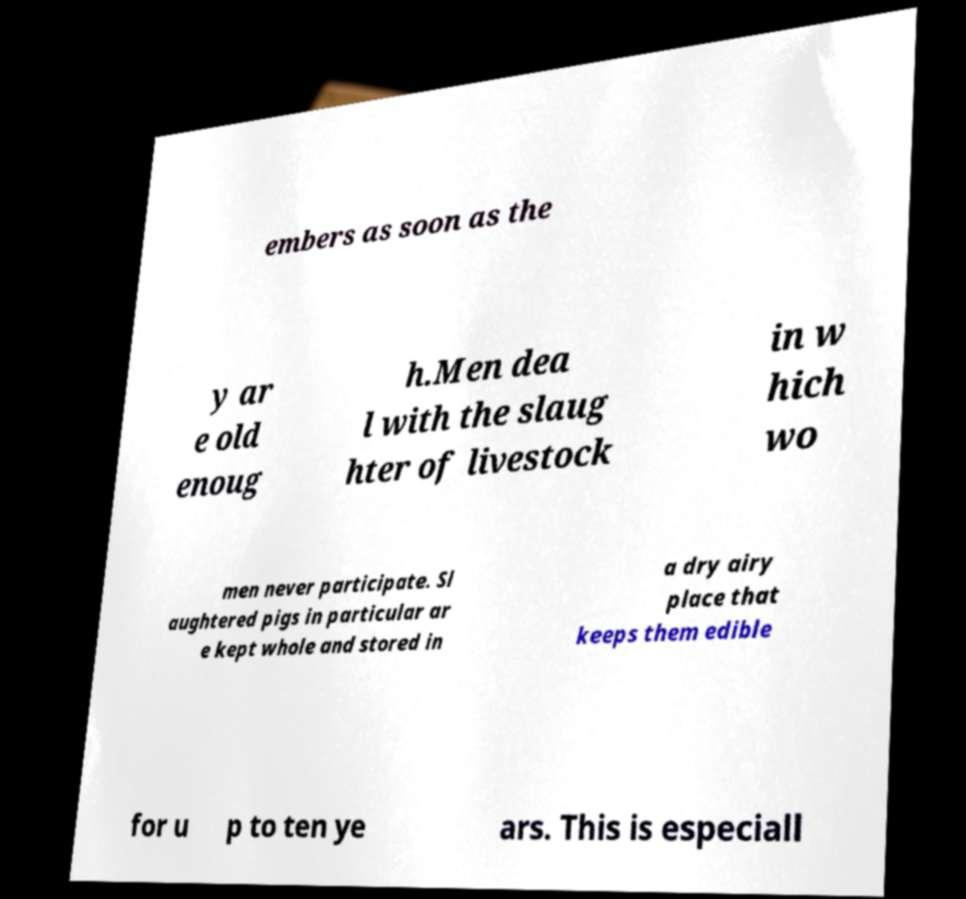For documentation purposes, I need the text within this image transcribed. Could you provide that? embers as soon as the y ar e old enoug h.Men dea l with the slaug hter of livestock in w hich wo men never participate. Sl aughtered pigs in particular ar e kept whole and stored in a dry airy place that keeps them edible for u p to ten ye ars. This is especiall 